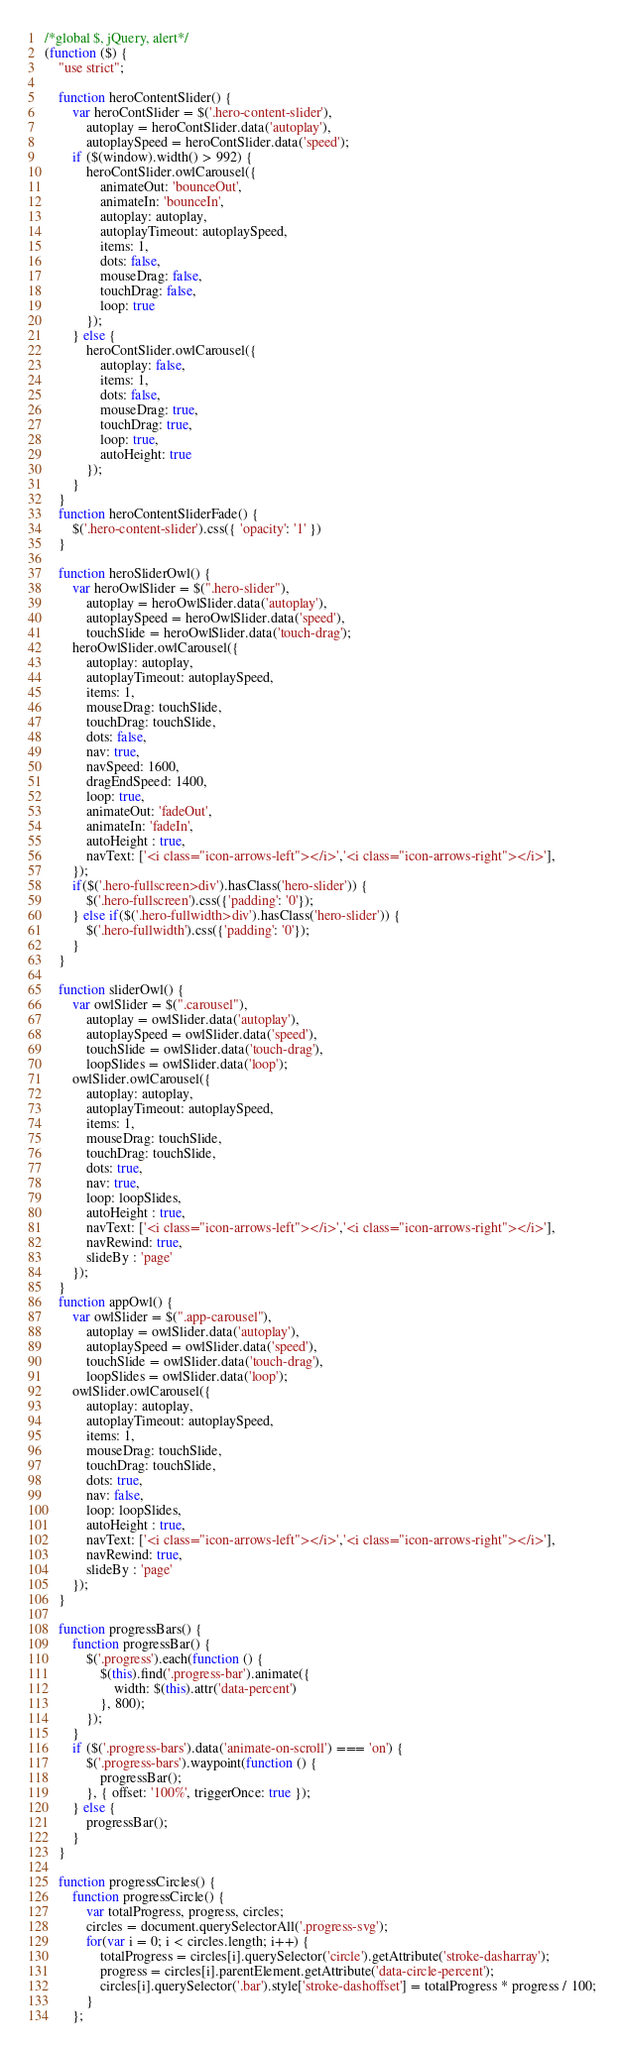Convert code to text. <code><loc_0><loc_0><loc_500><loc_500><_JavaScript_>/*global $, jQuery, alert*/
(function ($) {
    "use strict";
 
    function heroContentSlider() {
        var heroContSlider = $('.hero-content-slider'),
            autoplay = heroContSlider.data('autoplay'),
            autoplaySpeed = heroContSlider.data('speed');
        if ($(window).width() > 992) {
            heroContSlider.owlCarousel({
                animateOut: 'bounceOut',
                animateIn: 'bounceIn',
                autoplay: autoplay,
                autoplayTimeout: autoplaySpeed,
                items: 1,
                dots: false,
                mouseDrag: false,
                touchDrag: false,
                loop: true
            });
        } else {
            heroContSlider.owlCarousel({
                autoplay: false,
                items: 1,
                dots: false,
                mouseDrag: true,
                touchDrag: true,
                loop: true,
                autoHeight: true
            });
        }
    }
    function heroContentSliderFade() {
        $('.hero-content-slider').css({ 'opacity': '1' })
    }
    
    function heroSliderOwl() {
        var heroOwlSlider = $(".hero-slider"),
            autoplay = heroOwlSlider.data('autoplay'),
            autoplaySpeed = heroOwlSlider.data('speed'),
            touchSlide = heroOwlSlider.data('touch-drag');
        heroOwlSlider.owlCarousel({
            autoplay: autoplay,
            autoplayTimeout: autoplaySpeed,
            items: 1,
            mouseDrag: touchSlide,
            touchDrag: touchSlide,
            dots: false,
            nav: true,
            navSpeed: 1600,
            dragEndSpeed: 1400,
            loop: true,
            animateOut: 'fadeOut',
            animateIn: 'fadeIn',
            autoHeight : true,
            navText: ['<i class="icon-arrows-left"></i>','<i class="icon-arrows-right"></i>'],
        });
        if($('.hero-fullscreen>div').hasClass('hero-slider')) {
            $('.hero-fullscreen').css({'padding': '0'});
        } else if($('.hero-fullwidth>div').hasClass('hero-slider')) {
            $('.hero-fullwidth').css({'padding': '0'});
        }
    }
    
    function sliderOwl() {
        var owlSlider = $(".carousel"),
            autoplay = owlSlider.data('autoplay'),
            autoplaySpeed = owlSlider.data('speed'),
            touchSlide = owlSlider.data('touch-drag'),
            loopSlides = owlSlider.data('loop');
        owlSlider.owlCarousel({
            autoplay: autoplay,
            autoplayTimeout: autoplaySpeed,
            items: 1,
            mouseDrag: touchSlide,
            touchDrag: touchSlide,
            dots: true,
            nav: true,
            loop: loopSlides,
            autoHeight : true,
            navText: ['<i class="icon-arrows-left"></i>','<i class="icon-arrows-right"></i>'],
            navRewind: true,
            slideBy : 'page'
        });
    }
    function appOwl() {
        var owlSlider = $(".app-carousel"),
            autoplay = owlSlider.data('autoplay'),
            autoplaySpeed = owlSlider.data('speed'),
            touchSlide = owlSlider.data('touch-drag'),
            loopSlides = owlSlider.data('loop');
        owlSlider.owlCarousel({
            autoplay: autoplay,
            autoplayTimeout: autoplaySpeed,
            items: 1,
            mouseDrag: touchSlide,
            touchDrag: touchSlide,
            dots: true,
            nav: false,
            loop: loopSlides,
            autoHeight : true,
            navText: ['<i class="icon-arrows-left"></i>','<i class="icon-arrows-right"></i>'],
            navRewind: true,
            slideBy : 'page'
        });
    }
        
    function progressBars() {
        function progressBar() {
            $('.progress').each(function () {
                $(this).find('.progress-bar').animate({
                    width: $(this).attr('data-percent')
                }, 800);
            });
        }
        if ($('.progress-bars').data('animate-on-scroll') === 'on') {
            $('.progress-bars').waypoint(function () {
                progressBar();
            }, { offset: '100%', triggerOnce: true });
        } else {
            progressBar();
        }
    }
    
    function progressCircles() {
        function progressCircle() {
            var totalProgress, progress, circles;
            circles = document.querySelectorAll('.progress-svg');
            for(var i = 0; i < circles.length; i++) {
                totalProgress = circles[i].querySelector('circle').getAttribute('stroke-dasharray');
                progress = circles[i].parentElement.getAttribute('data-circle-percent');
                circles[i].querySelector('.bar').style['stroke-dashoffset'] = totalProgress * progress / 100;
            }
        };</code> 